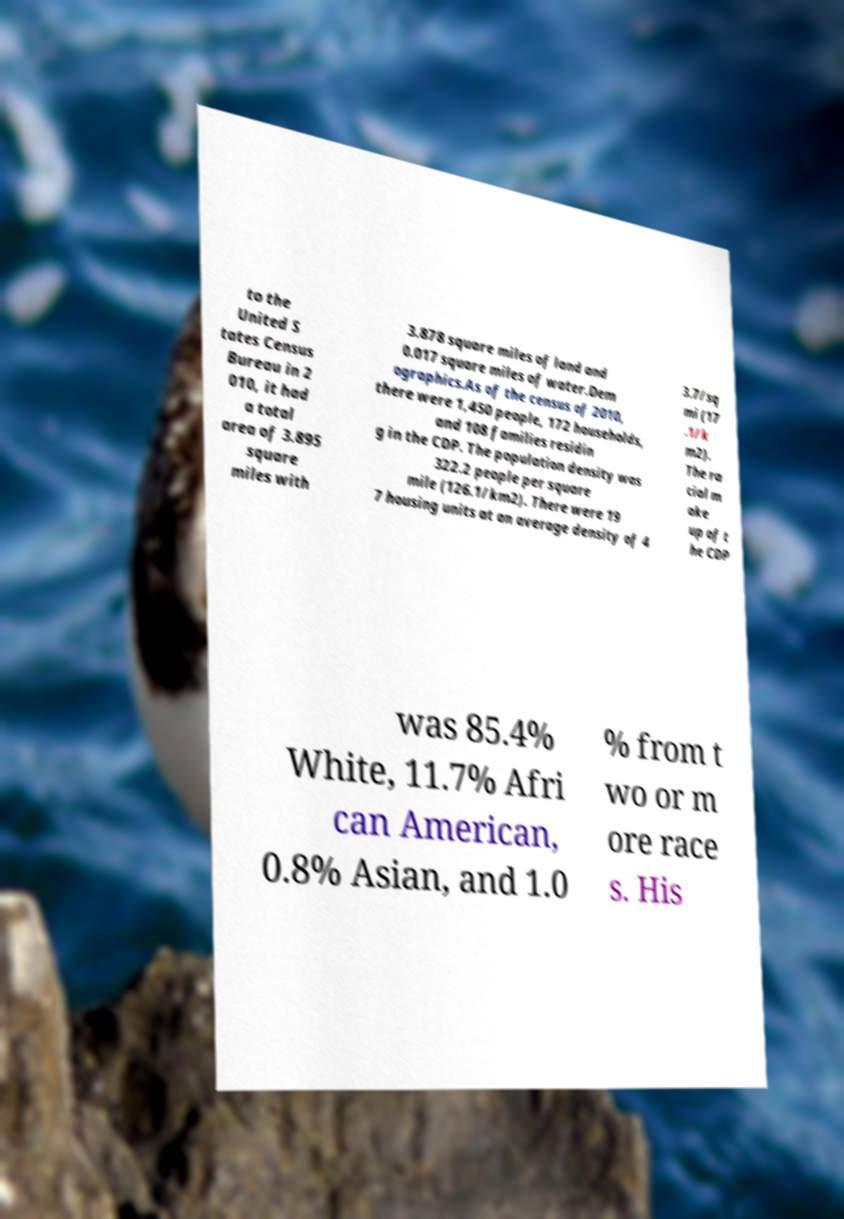Could you assist in decoding the text presented in this image and type it out clearly? to the United S tates Census Bureau in 2 010, it had a total area of 3.895 square miles with 3.878 square miles of land and 0.017 square miles of water.Dem ographics.As of the census of 2010, there were 1,450 people, 172 households, and 108 families residin g in the CDP. The population density was 322.2 people per square mile (126.1/km2). There were 19 7 housing units at an average density of 4 3.7/sq mi (17 .1/k m2). The ra cial m ake up of t he CDP was 85.4% White, 11.7% Afri can American, 0.8% Asian, and 1.0 % from t wo or m ore race s. His 